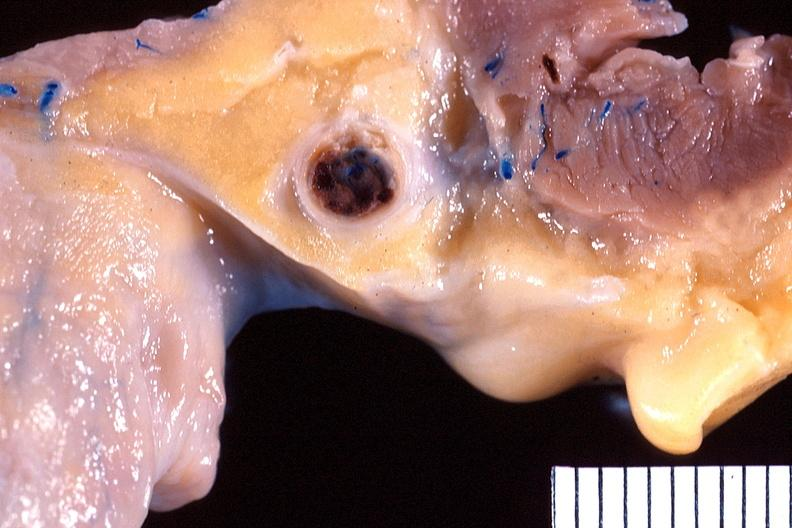what does this image show?
Answer the question using a single word or phrase. Heart 